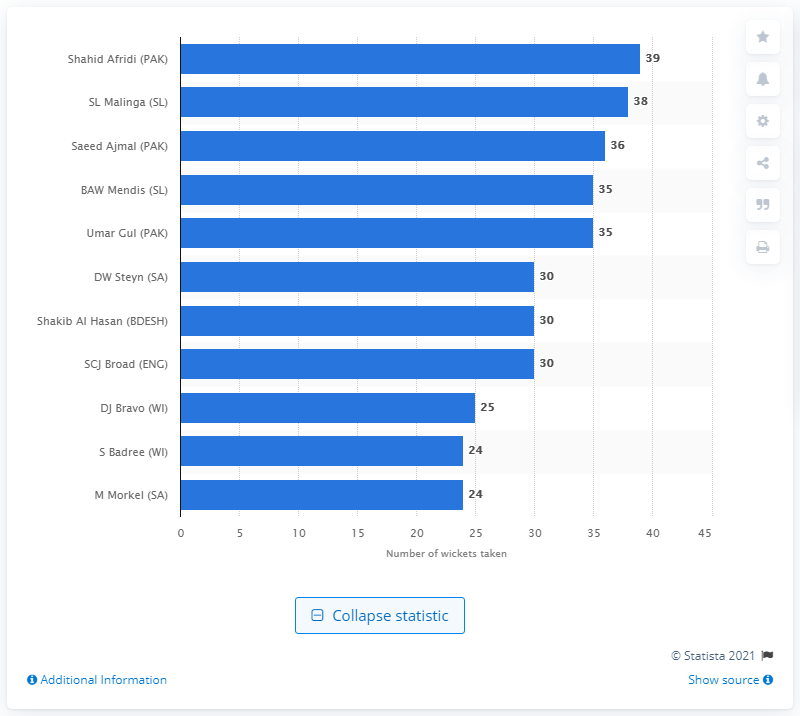Specify some key components in this picture. Afridi took 39 wickets between 2007 and 2016. 